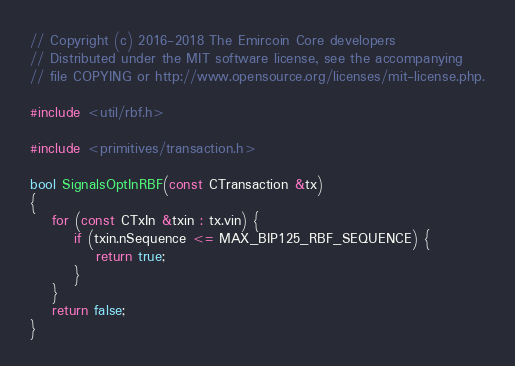Convert code to text. <code><loc_0><loc_0><loc_500><loc_500><_C++_>// Copyright (c) 2016-2018 The Emircoin Core developers
// Distributed under the MIT software license, see the accompanying
// file COPYING or http://www.opensource.org/licenses/mit-license.php.

#include <util/rbf.h>

#include <primitives/transaction.h>

bool SignalsOptInRBF(const CTransaction &tx)
{
    for (const CTxIn &txin : tx.vin) {
        if (txin.nSequence <= MAX_BIP125_RBF_SEQUENCE) {
            return true;
        }
    }
    return false;
}
</code> 